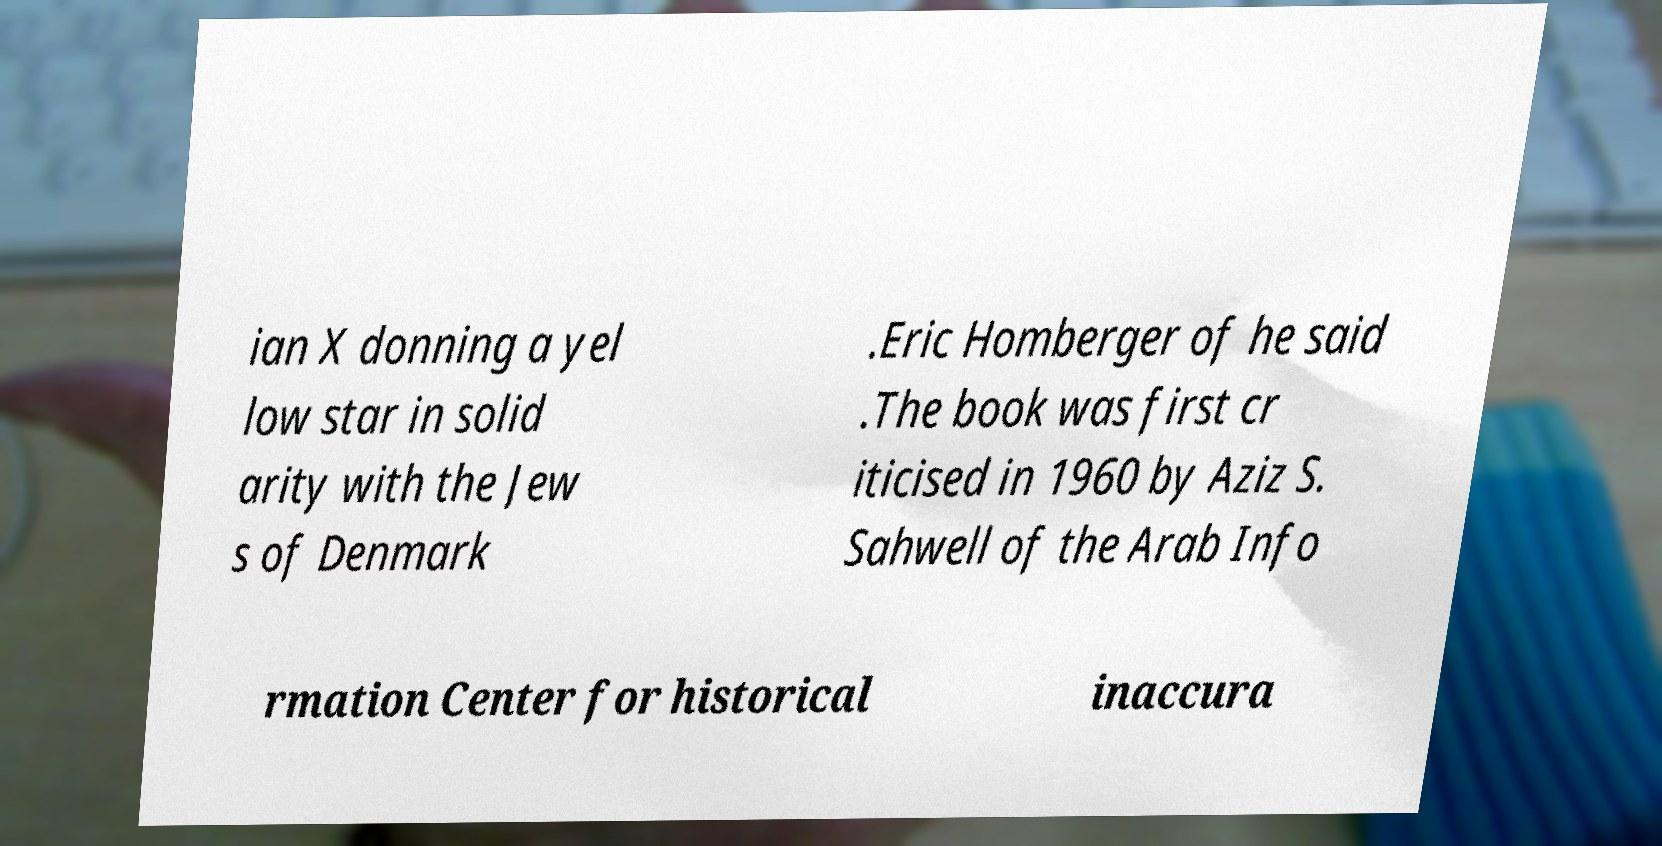Could you extract and type out the text from this image? ian X donning a yel low star in solid arity with the Jew s of Denmark .Eric Homberger of he said .The book was first cr iticised in 1960 by Aziz S. Sahwell of the Arab Info rmation Center for historical inaccura 